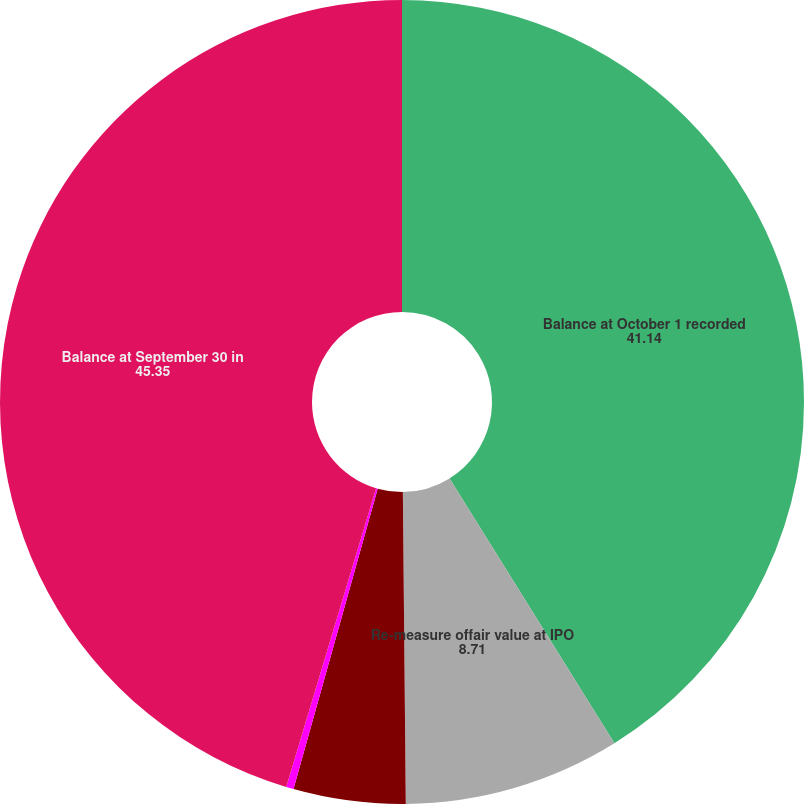Convert chart to OTSL. <chart><loc_0><loc_0><loc_500><loc_500><pie_chart><fcel>Balance at October 1 recorded<fcel>Re-measure offair value at IPO<fcel>Accretion recorded from IPO<fcel>Dividenddeclared (2)<fcel>Balance at September 30 in<nl><fcel>41.14%<fcel>8.71%<fcel>4.5%<fcel>0.3%<fcel>45.35%<nl></chart> 